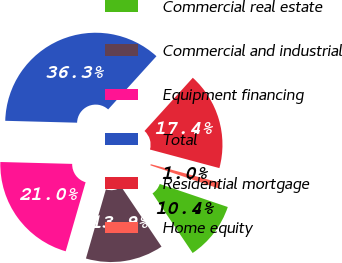Convert chart. <chart><loc_0><loc_0><loc_500><loc_500><pie_chart><fcel>Commercial real estate<fcel>Commercial and industrial<fcel>Equipment financing<fcel>Total<fcel>Residential mortgage<fcel>Home equity<nl><fcel>10.37%<fcel>13.9%<fcel>20.95%<fcel>36.31%<fcel>17.43%<fcel>1.04%<nl></chart> 